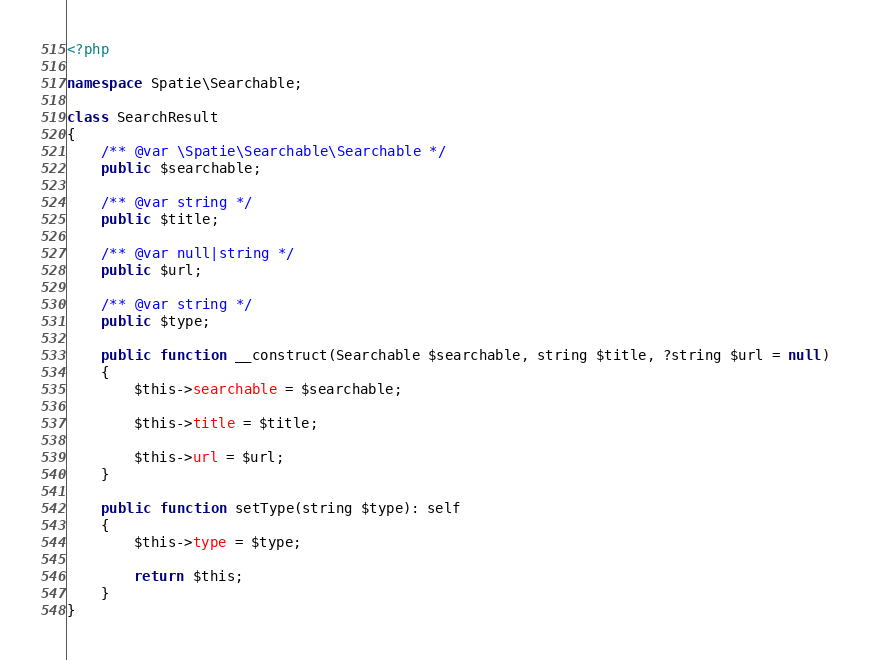Convert code to text. <code><loc_0><loc_0><loc_500><loc_500><_PHP_><?php

namespace Spatie\Searchable;

class SearchResult
{
    /** @var \Spatie\Searchable\Searchable */
    public $searchable;

    /** @var string */
    public $title;

    /** @var null|string */
    public $url;

    /** @var string */
    public $type;

    public function __construct(Searchable $searchable, string $title, ?string $url = null)
    {
        $this->searchable = $searchable;

        $this->title = $title;

        $this->url = $url;
    }

    public function setType(string $type): self
    {
        $this->type = $type;

        return $this;
    }
}
</code> 